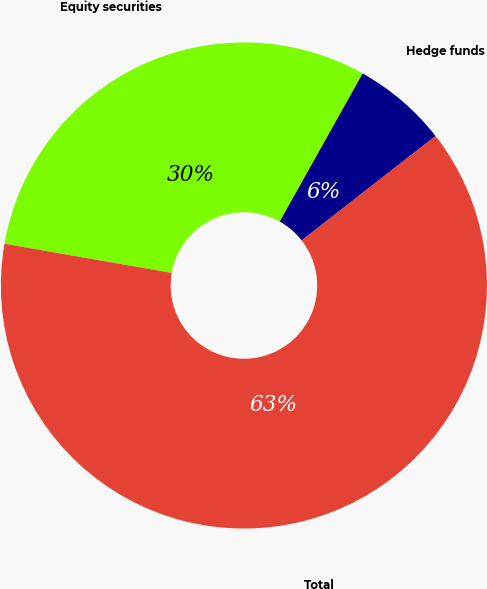Convert chart to OTSL. <chart><loc_0><loc_0><loc_500><loc_500><pie_chart><fcel>Equity securities<fcel>Hedge funds<fcel>Total<nl><fcel>30.38%<fcel>6.33%<fcel>63.29%<nl></chart> 